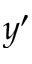<formula> <loc_0><loc_0><loc_500><loc_500>y ^ { \prime }</formula> 